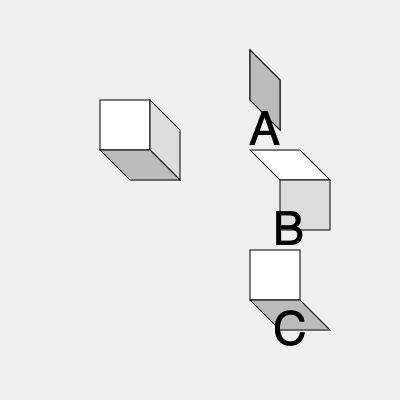As a digital literacy blogger explaining 3D modeling concepts, which of the options A, B, or C correctly represents the view of the original cube when rotated 90 degrees clockwise around its vertical axis? To solve this problem, let's follow these steps:

1. Understand the original cube:
   - The front face is white
   - The right face is light gray
   - The top face is dark gray

2. Visualize the 90-degree clockwise rotation around the vertical axis:
   - The front face will become the left face
   - The right face will become the front face
   - The top face will remain on top

3. Analyze each option:
   A: This shows the right and back faces, which is incorrect
   B: This shows the top and right faces, which is correct
   C: This shows the front and bottom faces, which is incorrect

4. Compare with the correct rotation:
   - Option B matches our expectation:
     * The light gray face (originally on the right) is now in front
     * The white face (originally in front) is not visible as it's now on the left
     * The dark gray top face remains visible on top

Therefore, option B correctly represents the cube after a 90-degree clockwise rotation around its vertical axis.
Answer: B 